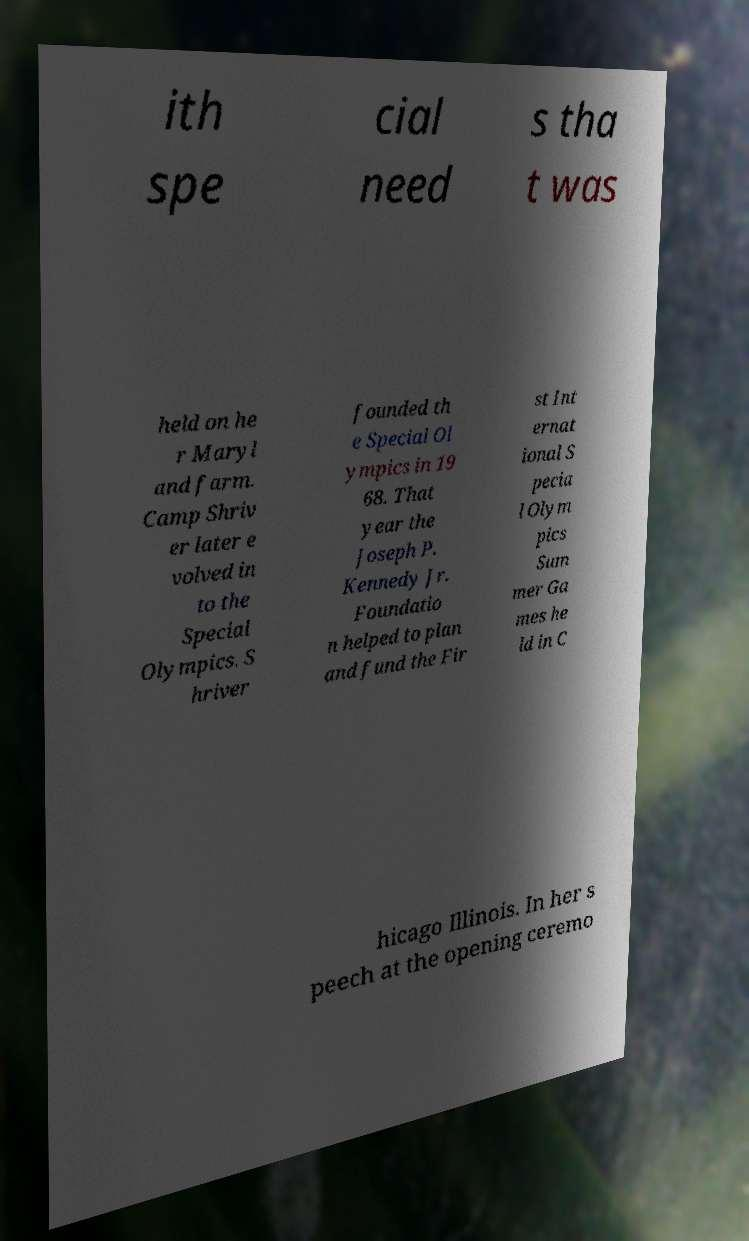Please read and relay the text visible in this image. What does it say? ith spe cial need s tha t was held on he r Maryl and farm. Camp Shriv er later e volved in to the Special Olympics. S hriver founded th e Special Ol ympics in 19 68. That year the Joseph P. Kennedy Jr. Foundatio n helped to plan and fund the Fir st Int ernat ional S pecia l Olym pics Sum mer Ga mes he ld in C hicago Illinois. In her s peech at the opening ceremo 